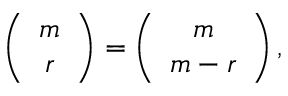<formula> <loc_0><loc_0><loc_500><loc_500>\left ( \begin{array} { c } { m } \\ { r } \end{array} \right ) = \left ( \begin{array} { c } { m } \\ { m - r } \end{array} \right ) ,</formula> 